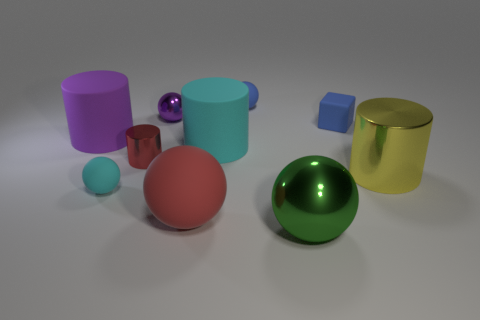Is the number of big purple things greater than the number of metallic objects?
Your answer should be very brief. No. There is a metallic thing that is right of the big rubber ball and behind the large red sphere; what is its size?
Keep it short and to the point. Large. What is the material of the thing that is the same color as the block?
Keep it short and to the point. Rubber. Are there an equal number of big yellow objects in front of the yellow thing and big cyan things?
Keep it short and to the point. No. Is the matte cube the same size as the purple metallic object?
Your response must be concise. Yes. What is the color of the thing that is both in front of the tiny shiny cylinder and left of the small red thing?
Make the answer very short. Cyan. What is the material of the purple thing that is behind the blue thing right of the large green shiny object?
Make the answer very short. Metal. What size is the red matte thing that is the same shape as the green shiny thing?
Give a very brief answer. Large. Does the big rubber thing that is in front of the large metallic cylinder have the same color as the small metal cylinder?
Your answer should be very brief. Yes. Is the number of big red objects less than the number of shiny cylinders?
Your response must be concise. Yes. 